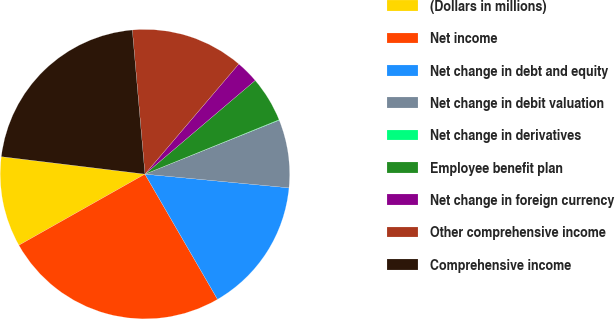Convert chart. <chart><loc_0><loc_0><loc_500><loc_500><pie_chart><fcel>(Dollars in millions)<fcel>Net income<fcel>Net change in debt and equity<fcel>Net change in debit valuation<fcel>Net change in derivatives<fcel>Employee benefit plan<fcel>Net change in foreign currency<fcel>Other comprehensive income<fcel>Comprehensive income<nl><fcel>10.1%<fcel>25.19%<fcel>15.13%<fcel>7.59%<fcel>0.05%<fcel>5.08%<fcel>2.56%<fcel>12.62%<fcel>21.68%<nl></chart> 